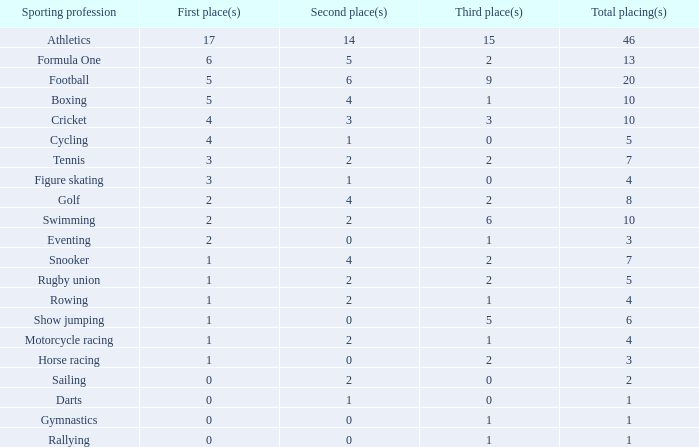How many second position appearances does snooker have? 4.0. 